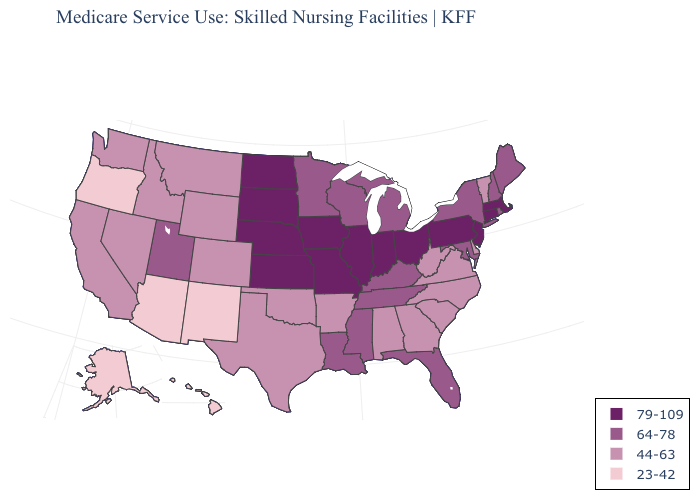Does Ohio have the same value as Arizona?
Write a very short answer. No. Does Nevada have the highest value in the West?
Concise answer only. No. Name the states that have a value in the range 23-42?
Be succinct. Alaska, Arizona, Hawaii, New Mexico, Oregon. What is the value of New Hampshire?
Quick response, please. 64-78. Name the states that have a value in the range 23-42?
Concise answer only. Alaska, Arizona, Hawaii, New Mexico, Oregon. Does Oregon have the lowest value in the West?
Quick response, please. Yes. Does Oklahoma have the same value as New Mexico?
Write a very short answer. No. Does Arizona have the lowest value in the USA?
Answer briefly. Yes. Name the states that have a value in the range 79-109?
Keep it brief. Connecticut, Illinois, Indiana, Iowa, Kansas, Massachusetts, Missouri, Nebraska, New Jersey, North Dakota, Ohio, Pennsylvania, South Dakota. Which states hav the highest value in the MidWest?
Quick response, please. Illinois, Indiana, Iowa, Kansas, Missouri, Nebraska, North Dakota, Ohio, South Dakota. Does Louisiana have the highest value in the South?
Be succinct. Yes. Is the legend a continuous bar?
Concise answer only. No. What is the highest value in the USA?
Concise answer only. 79-109. What is the value of Ohio?
Keep it brief. 79-109. Does Nevada have the highest value in the USA?
Keep it brief. No. 